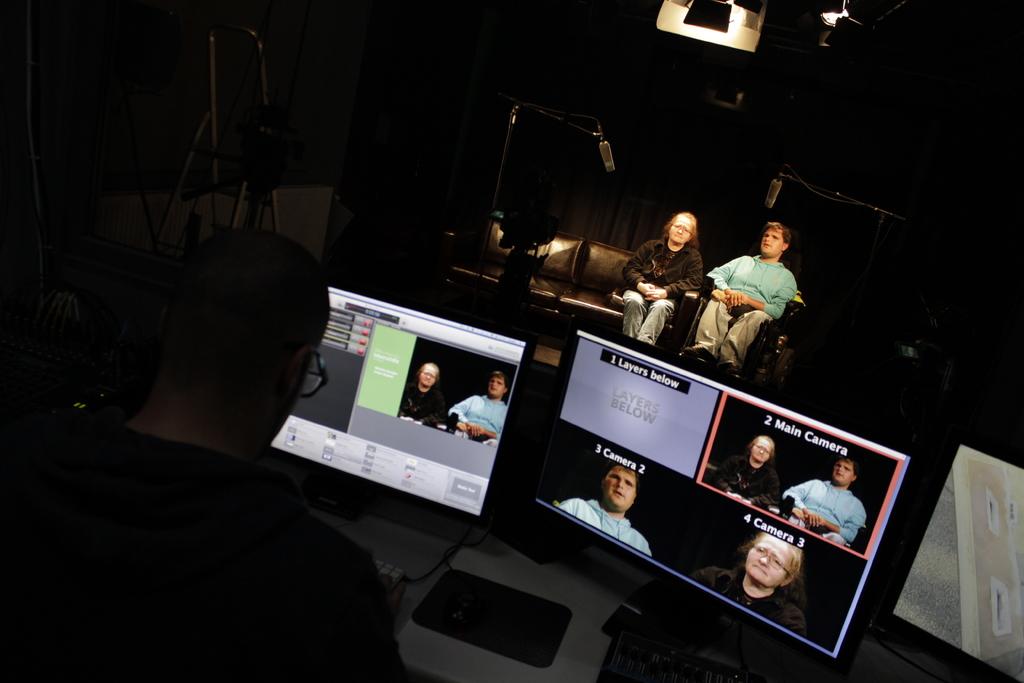What is seen on camera 1?
Keep it short and to the point. Layers below. 